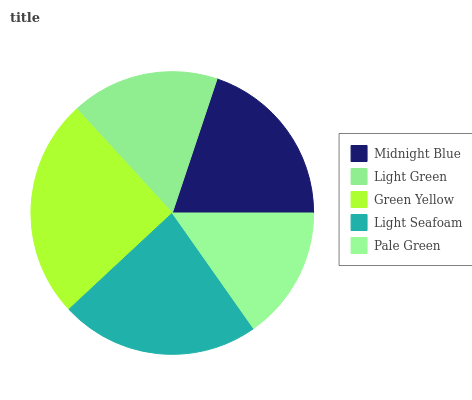Is Pale Green the minimum?
Answer yes or no. Yes. Is Green Yellow the maximum?
Answer yes or no. Yes. Is Light Green the minimum?
Answer yes or no. No. Is Light Green the maximum?
Answer yes or no. No. Is Midnight Blue greater than Light Green?
Answer yes or no. Yes. Is Light Green less than Midnight Blue?
Answer yes or no. Yes. Is Light Green greater than Midnight Blue?
Answer yes or no. No. Is Midnight Blue less than Light Green?
Answer yes or no. No. Is Midnight Blue the high median?
Answer yes or no. Yes. Is Midnight Blue the low median?
Answer yes or no. Yes. Is Light Green the high median?
Answer yes or no. No. Is Pale Green the low median?
Answer yes or no. No. 